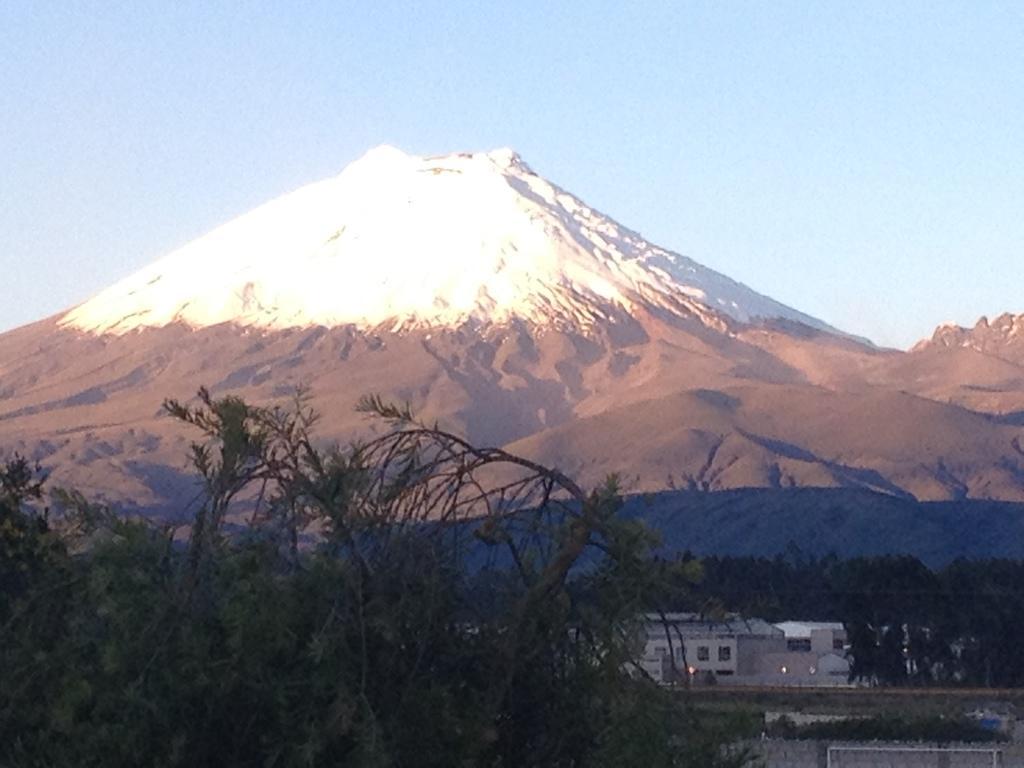Could you give a brief overview of what you see in this image? In this image we can see buildings, trees, plants and mountains, in the background we can see the clear sky. 